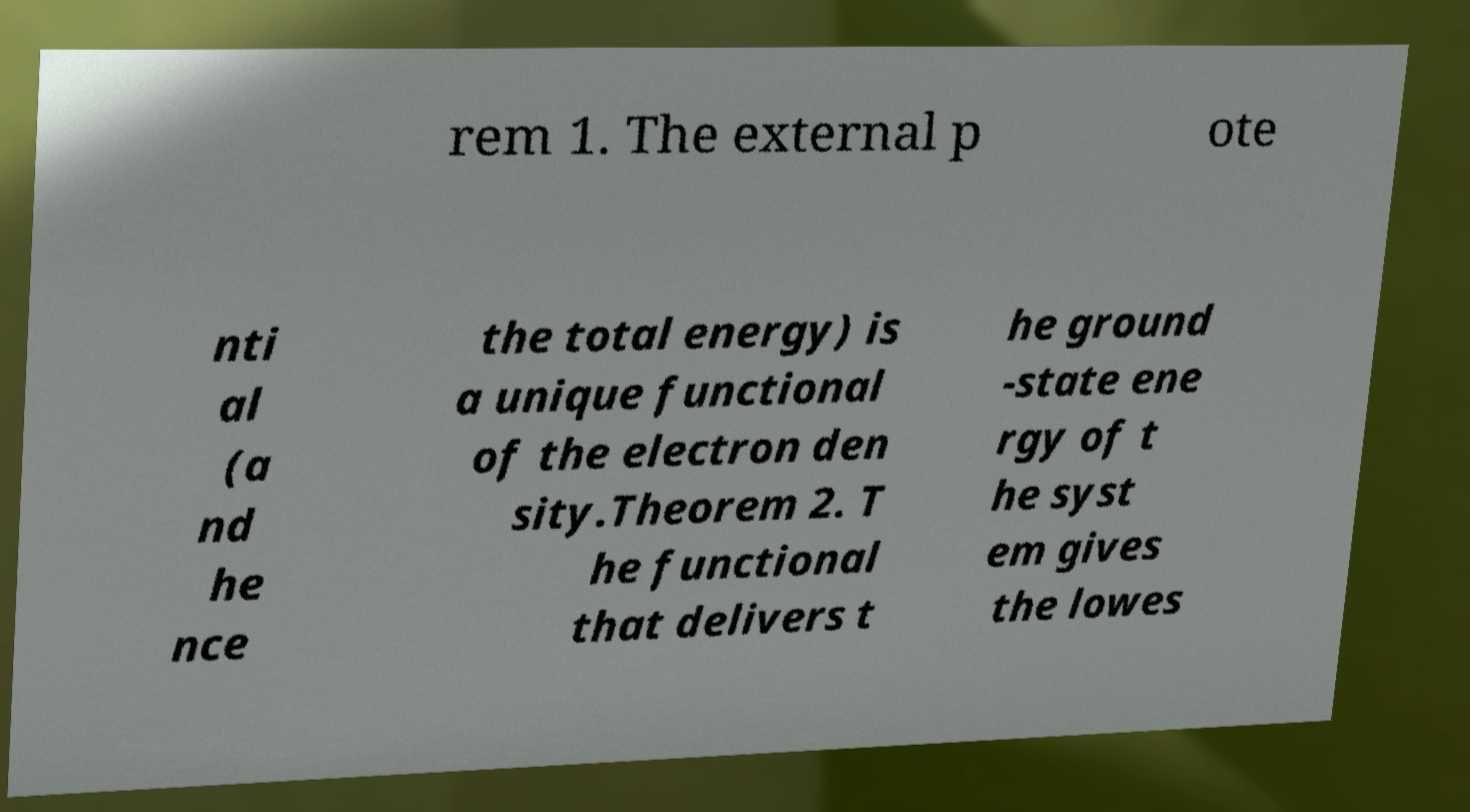Can you read and provide the text displayed in the image?This photo seems to have some interesting text. Can you extract and type it out for me? rem 1. The external p ote nti al (a nd he nce the total energy) is a unique functional of the electron den sity.Theorem 2. T he functional that delivers t he ground -state ene rgy of t he syst em gives the lowes 